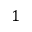Convert formula to latex. <formula><loc_0><loc_0><loc_500><loc_500>1</formula> 